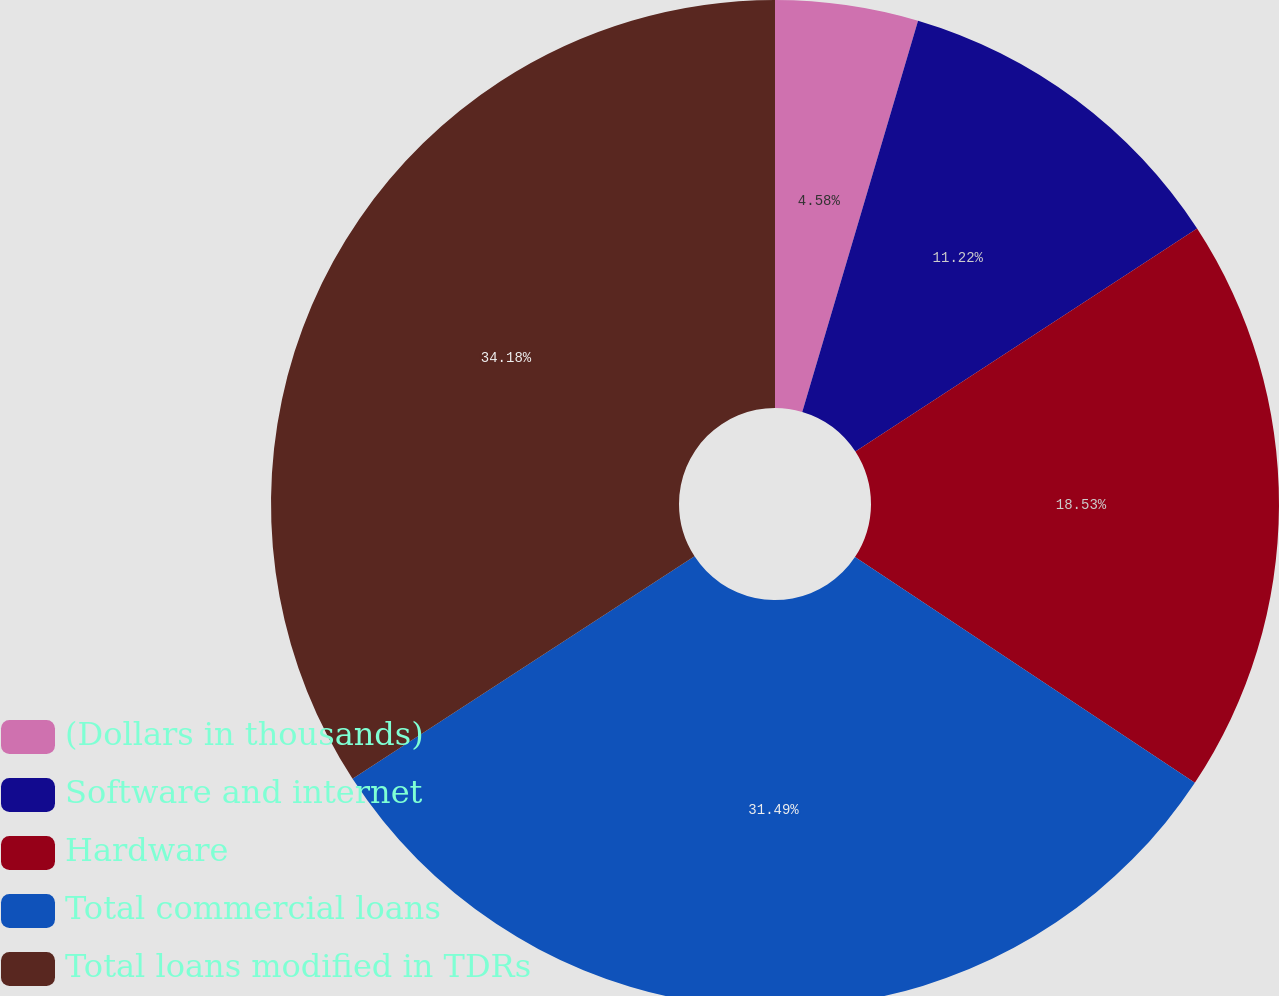Convert chart. <chart><loc_0><loc_0><loc_500><loc_500><pie_chart><fcel>(Dollars in thousands)<fcel>Software and internet<fcel>Hardware<fcel>Total commercial loans<fcel>Total loans modified in TDRs<nl><fcel>4.58%<fcel>11.22%<fcel>18.53%<fcel>31.49%<fcel>34.18%<nl></chart> 